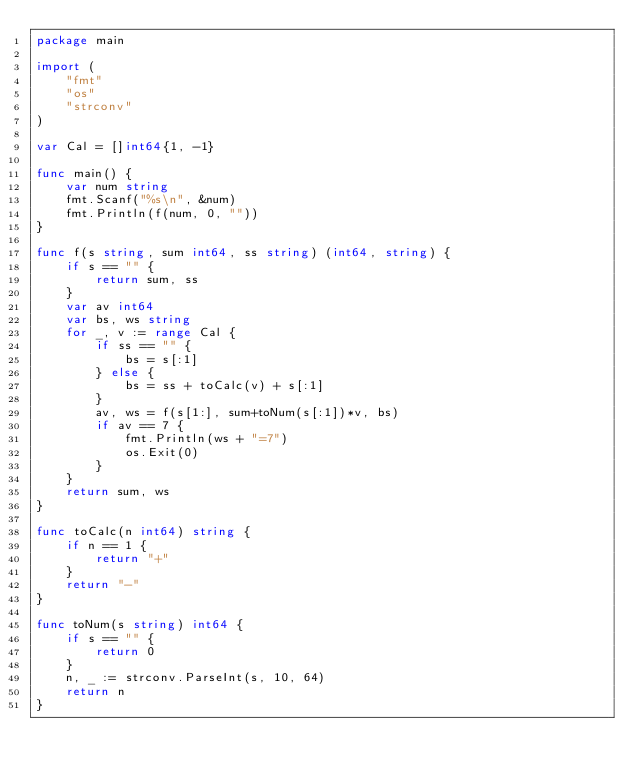Convert code to text. <code><loc_0><loc_0><loc_500><loc_500><_Go_>package main

import (
	"fmt"
	"os"
	"strconv"
)

var Cal = []int64{1, -1}

func main() {
	var num string
	fmt.Scanf("%s\n", &num)
	fmt.Println(f(num, 0, ""))
}

func f(s string, sum int64, ss string) (int64, string) {
	if s == "" {
		return sum, ss
	}
	var av int64
	var bs, ws string
	for _, v := range Cal {
		if ss == "" {
			bs = s[:1]
		} else {
			bs = ss + toCalc(v) + s[:1]
		}
		av, ws = f(s[1:], sum+toNum(s[:1])*v, bs)
		if av == 7 {
			fmt.Println(ws + "=7")
			os.Exit(0)
		}
	}
	return sum, ws
}

func toCalc(n int64) string {
	if n == 1 {
		return "+"
	}
	return "-"
}

func toNum(s string) int64 {
	if s == "" {
		return 0
	}
	n, _ := strconv.ParseInt(s, 10, 64)
	return n
}
</code> 